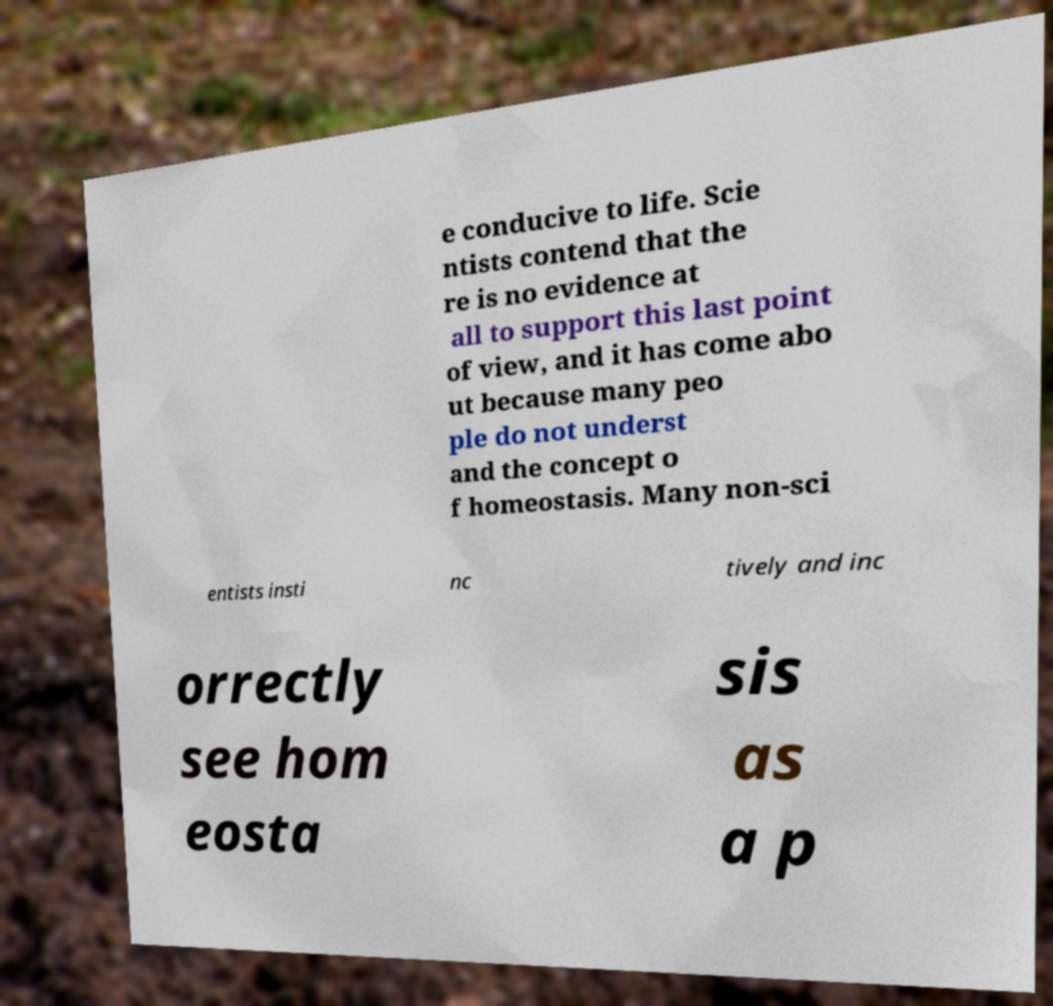Please identify and transcribe the text found in this image. e conducive to life. Scie ntists contend that the re is no evidence at all to support this last point of view, and it has come abo ut because many peo ple do not underst and the concept o f homeostasis. Many non-sci entists insti nc tively and inc orrectly see hom eosta sis as a p 